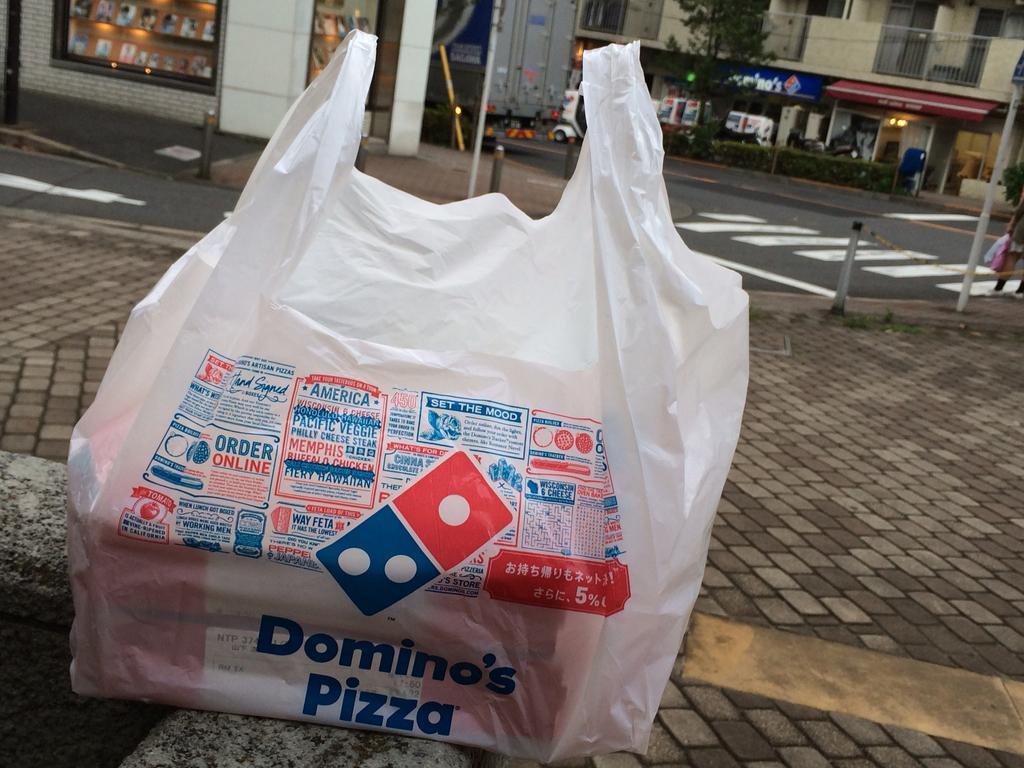Please provide a concise description of this image. We can see cover on the surface, poles, tree and there is a person standing and holding covers. In the background we can see vehicles on the road, buildings, plants, tree and railings. 